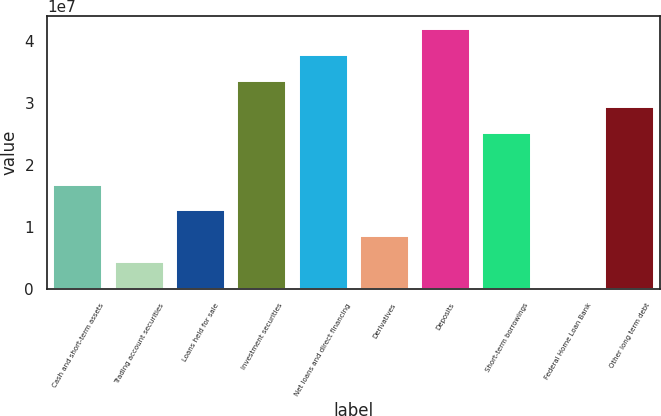Convert chart to OTSL. <chart><loc_0><loc_0><loc_500><loc_500><bar_chart><fcel>Cash and short-term assets<fcel>Trading account securities<fcel>Loans held for sale<fcel>Investment securities<fcel>Net loans and direct financing<fcel>Derivatives<fcel>Deposits<fcel>Short-term borrowings<fcel>Federal Home Loan Bank<fcel>Other long term debt<nl><fcel>1.68451e+07<fcel>4.34066e+06<fcel>1.26769e+07<fcel>3.35176e+07<fcel>3.76858e+07<fcel>8.50879e+06<fcel>4.18539e+07<fcel>2.51813e+07<fcel>172519<fcel>2.93495e+07<nl></chart> 